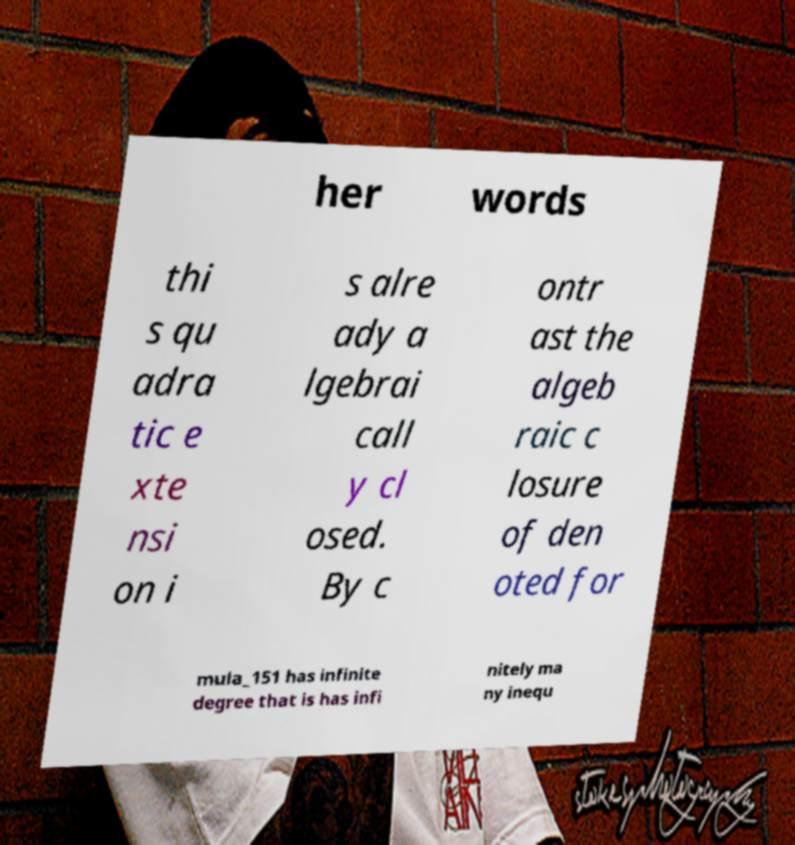I need the written content from this picture converted into text. Can you do that? her words thi s qu adra tic e xte nsi on i s alre ady a lgebrai call y cl osed. By c ontr ast the algeb raic c losure of den oted for mula_151 has infinite degree that is has infi nitely ma ny inequ 